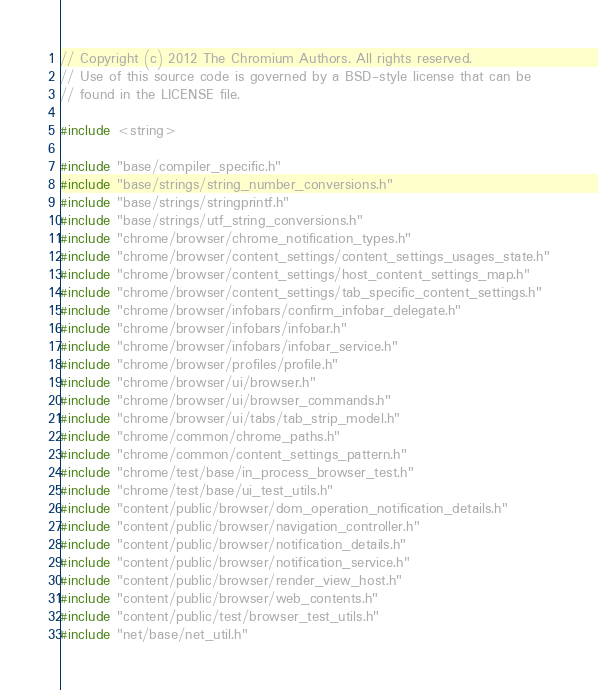<code> <loc_0><loc_0><loc_500><loc_500><_C++_>// Copyright (c) 2012 The Chromium Authors. All rights reserved.
// Use of this source code is governed by a BSD-style license that can be
// found in the LICENSE file.

#include <string>

#include "base/compiler_specific.h"
#include "base/strings/string_number_conversions.h"
#include "base/strings/stringprintf.h"
#include "base/strings/utf_string_conversions.h"
#include "chrome/browser/chrome_notification_types.h"
#include "chrome/browser/content_settings/content_settings_usages_state.h"
#include "chrome/browser/content_settings/host_content_settings_map.h"
#include "chrome/browser/content_settings/tab_specific_content_settings.h"
#include "chrome/browser/infobars/confirm_infobar_delegate.h"
#include "chrome/browser/infobars/infobar.h"
#include "chrome/browser/infobars/infobar_service.h"
#include "chrome/browser/profiles/profile.h"
#include "chrome/browser/ui/browser.h"
#include "chrome/browser/ui/browser_commands.h"
#include "chrome/browser/ui/tabs/tab_strip_model.h"
#include "chrome/common/chrome_paths.h"
#include "chrome/common/content_settings_pattern.h"
#include "chrome/test/base/in_process_browser_test.h"
#include "chrome/test/base/ui_test_utils.h"
#include "content/public/browser/dom_operation_notification_details.h"
#include "content/public/browser/navigation_controller.h"
#include "content/public/browser/notification_details.h"
#include "content/public/browser/notification_service.h"
#include "content/public/browser/render_view_host.h"
#include "content/public/browser/web_contents.h"
#include "content/public/test/browser_test_utils.h"
#include "net/base/net_util.h"</code> 